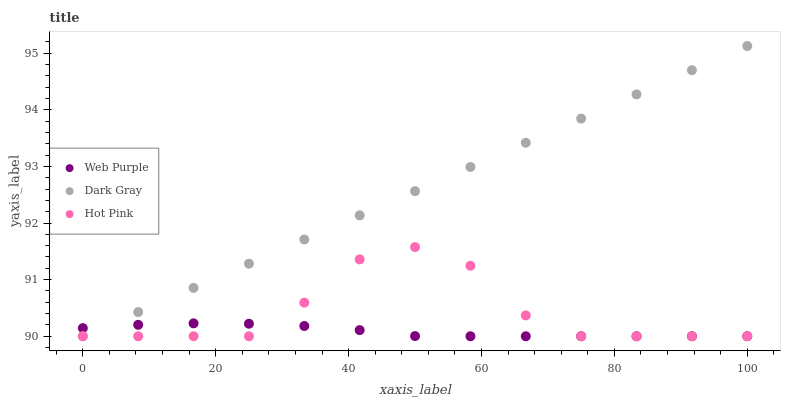Does Web Purple have the minimum area under the curve?
Answer yes or no. Yes. Does Dark Gray have the maximum area under the curve?
Answer yes or no. Yes. Does Hot Pink have the minimum area under the curve?
Answer yes or no. No. Does Hot Pink have the maximum area under the curve?
Answer yes or no. No. Is Dark Gray the smoothest?
Answer yes or no. Yes. Is Hot Pink the roughest?
Answer yes or no. Yes. Is Web Purple the smoothest?
Answer yes or no. No. Is Web Purple the roughest?
Answer yes or no. No. Does Dark Gray have the lowest value?
Answer yes or no. Yes. Does Dark Gray have the highest value?
Answer yes or no. Yes. Does Hot Pink have the highest value?
Answer yes or no. No. Does Web Purple intersect Hot Pink?
Answer yes or no. Yes. Is Web Purple less than Hot Pink?
Answer yes or no. No. Is Web Purple greater than Hot Pink?
Answer yes or no. No. 